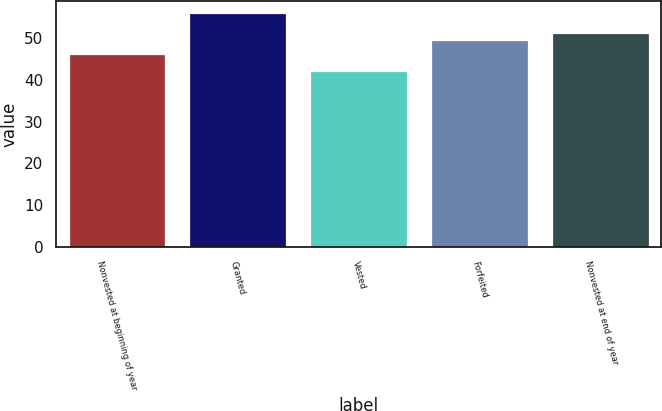Convert chart to OTSL. <chart><loc_0><loc_0><loc_500><loc_500><bar_chart><fcel>Nonvested at beginning of year<fcel>Granted<fcel>Vested<fcel>Forfeited<fcel>Nonvested at end of year<nl><fcel>46.33<fcel>56.09<fcel>42.08<fcel>49.61<fcel>51.17<nl></chart> 